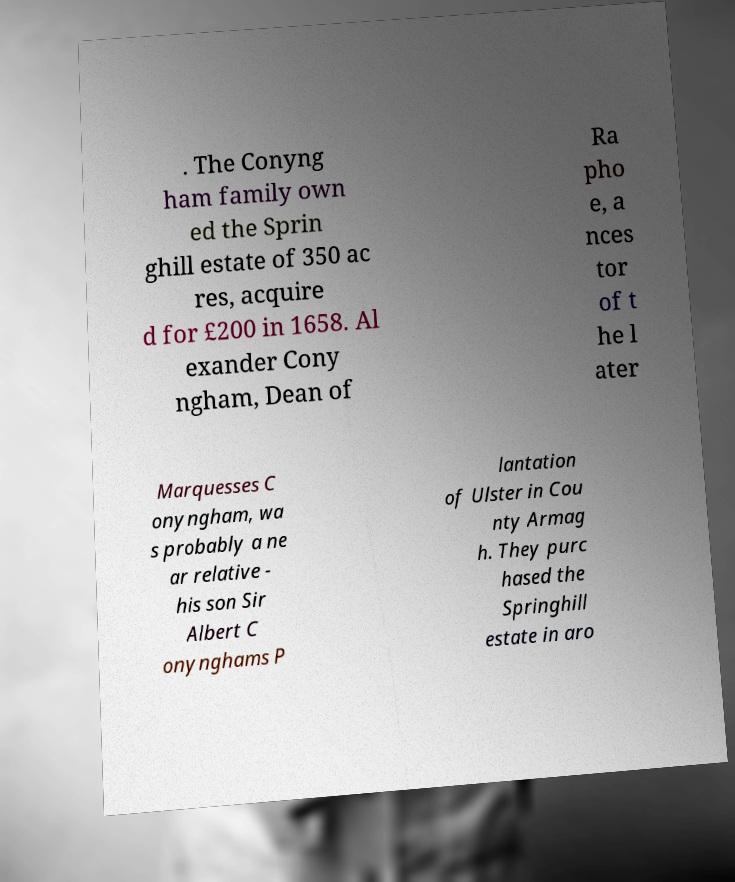There's text embedded in this image that I need extracted. Can you transcribe it verbatim? . The Conyng ham family own ed the Sprin ghill estate of 350 ac res, acquire d for £200 in 1658. Al exander Cony ngham, Dean of Ra pho e, a nces tor of t he l ater Marquesses C onyngham, wa s probably a ne ar relative - his son Sir Albert C onynghams P lantation of Ulster in Cou nty Armag h. They purc hased the Springhill estate in aro 